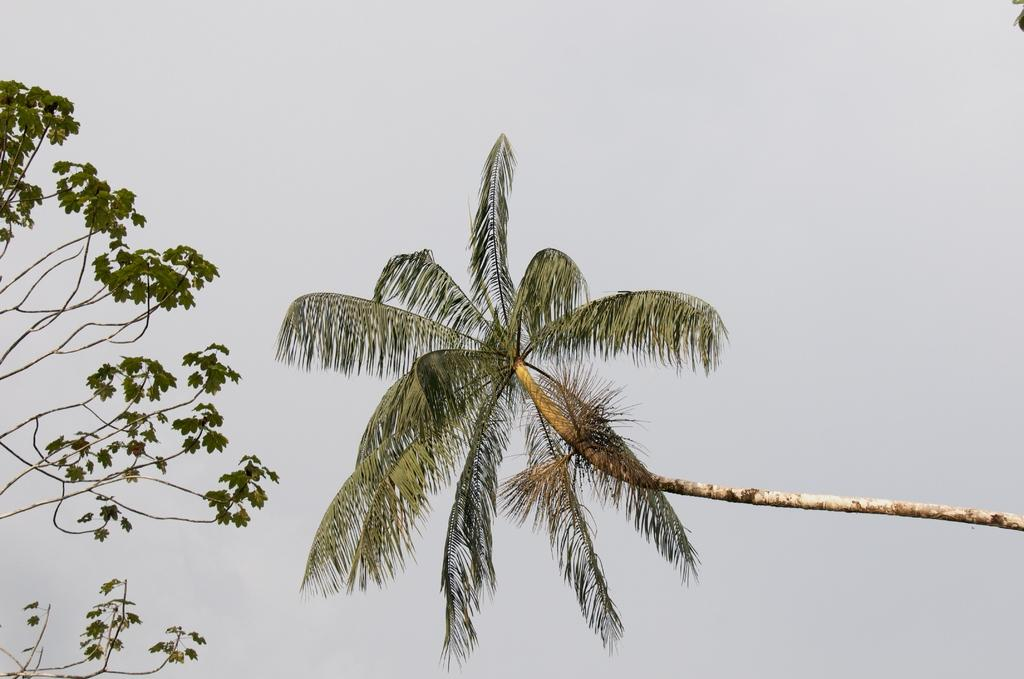What can be seen in the middle of the image? There are two trees in the middle of the image. What is visible in the background of the image? The sky is visible in the background of the image. What type of dress is hanging from one of the trees in the image? There is no dress present in the image; it only features two trees and the sky in the background. 